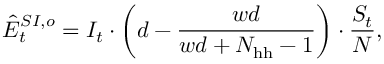<formula> <loc_0><loc_0><loc_500><loc_500>\hat { E } _ { t } ^ { S I , o } = I _ { t } \cdot \left ( d - \frac { w d } { w d + N _ { h h } - 1 } \right ) \cdot \frac { S _ { t } } { N } ,</formula> 